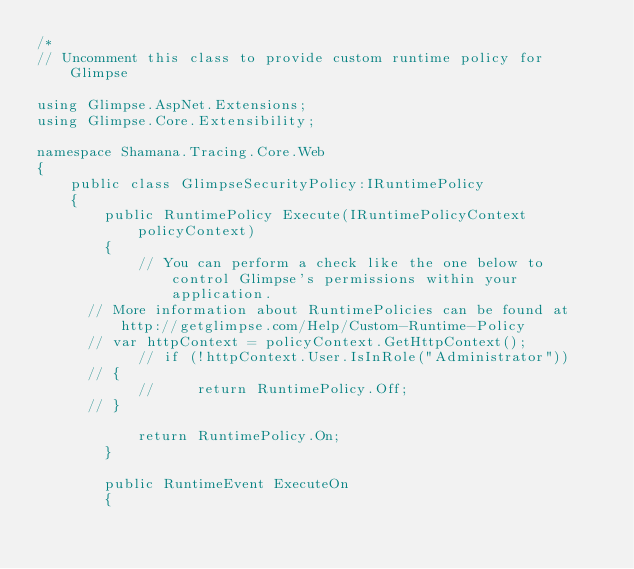Convert code to text. <code><loc_0><loc_0><loc_500><loc_500><_C#_>/*
// Uncomment this class to provide custom runtime policy for Glimpse

using Glimpse.AspNet.Extensions;
using Glimpse.Core.Extensibility;

namespace Shamana.Tracing.Core.Web
{
    public class GlimpseSecurityPolicy:IRuntimePolicy
    {
        public RuntimePolicy Execute(IRuntimePolicyContext policyContext)
        {
            // You can perform a check like the one below to control Glimpse's permissions within your application.
			// More information about RuntimePolicies can be found at http://getglimpse.com/Help/Custom-Runtime-Policy
			// var httpContext = policyContext.GetHttpContext();
            // if (!httpContext.User.IsInRole("Administrator"))
			// {
            //     return RuntimePolicy.Off;
			// }

            return RuntimePolicy.On;
        }

        public RuntimeEvent ExecuteOn
        {</code> 